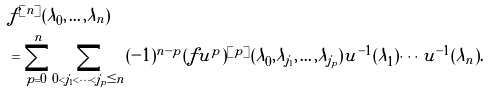Convert formula to latex. <formula><loc_0><loc_0><loc_500><loc_500>& f ^ { [ n ] } ( \lambda _ { 0 } , \dots , \lambda _ { n } ) \\ & = \sum _ { p = 0 } ^ { n } \sum _ { 0 < j _ { 1 } < \cdots < j _ { p } \leq n } ( - 1 ) ^ { n - p } ( f u ^ { p } ) ^ { [ p ] } ( \lambda _ { 0 } , \lambda _ { j _ { 1 } } , \dots , \lambda _ { j _ { p } } ) u ^ { - 1 } ( \lambda _ { 1 } ) \cdots u ^ { - 1 } ( \lambda _ { n } ) .</formula> 